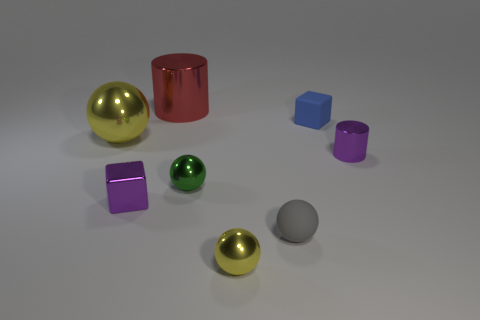Subtract all gray rubber spheres. How many spheres are left? 3 Subtract all purple cylinders. How many cylinders are left? 1 Subtract all cubes. How many objects are left? 6 Add 2 big gray metal things. How many objects exist? 10 Subtract all cyan balls. How many purple cylinders are left? 1 Add 1 large cylinders. How many large cylinders are left? 2 Add 5 big yellow things. How many big yellow things exist? 6 Subtract 0 yellow cylinders. How many objects are left? 8 Subtract 4 spheres. How many spheres are left? 0 Subtract all blue cubes. Subtract all brown cylinders. How many cubes are left? 1 